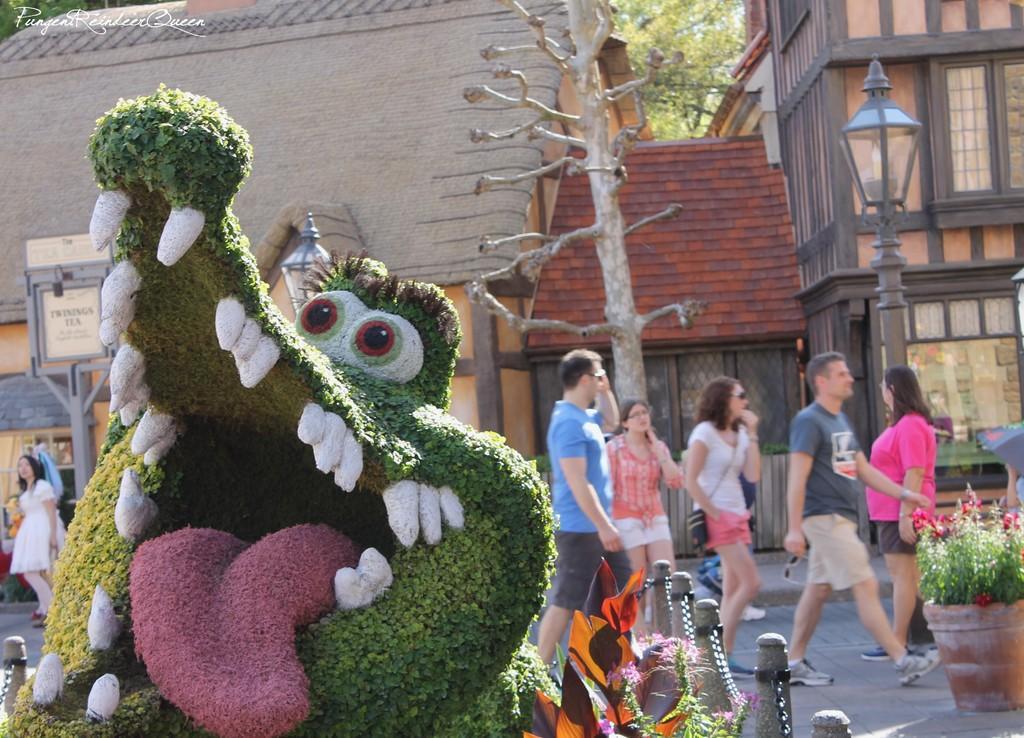Describe this image in one or two sentences. In this image there is a statue, in the background people are walking on road and there are trees and houses. 